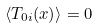<formula> <loc_0><loc_0><loc_500><loc_500>\left \langle T _ { 0 i } ( x ) \right \rangle = 0</formula> 